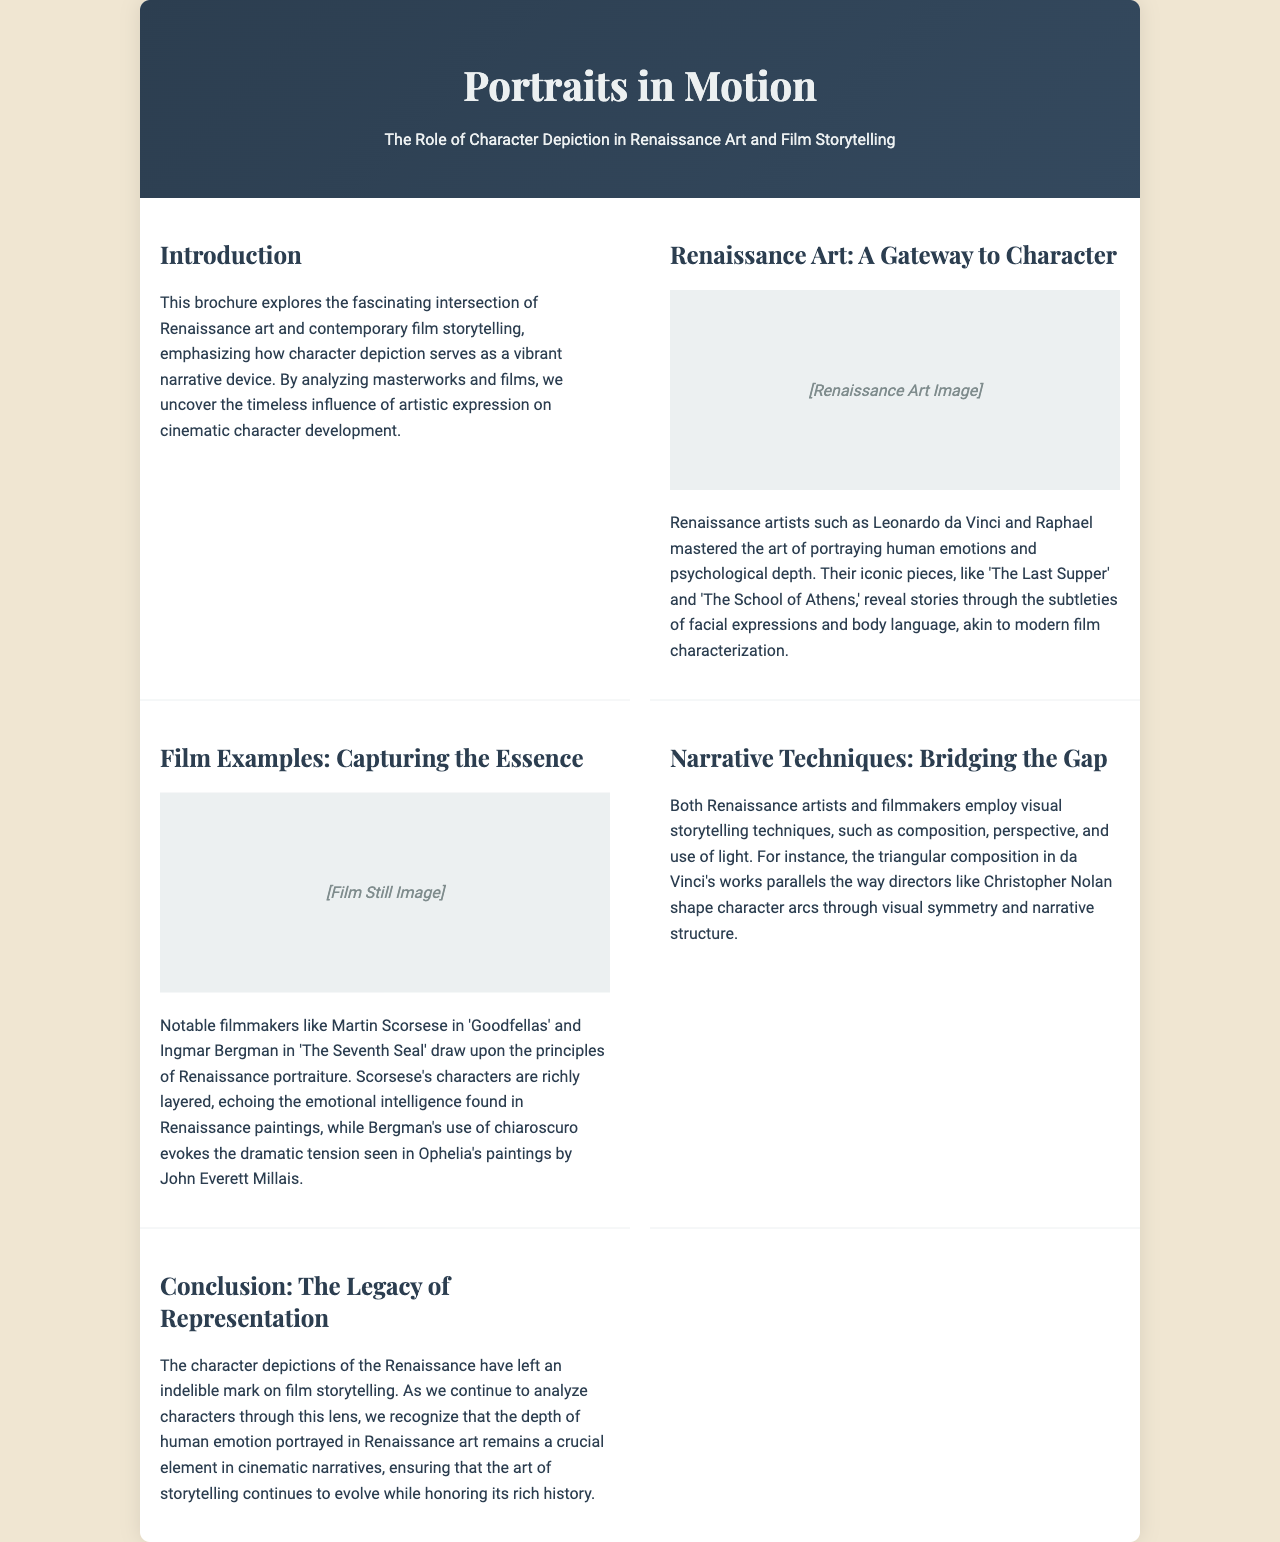What is the title of the brochure? The title is clearly stated at the top of the document, which is "Portraits in Motion."
Answer: Portraits in Motion Who are two Renaissance artists mentioned? The document lists Leonardo da Vinci and Raphael as examples of Renaissance artists.
Answer: Leonardo da Vinci and Raphael Name one film by Martin Scorsese referenced in the brochure. The brochure specifically mentions "Goodfellas" as a film by Martin Scorsese.
Answer: Goodfellas What narrative technique is used by both Renaissance artists and filmmakers? The document highlights the use of composition as a narrative technique common to both.
Answer: Composition What influences contemporary film storytelling according to the brochure? The brochure states that character depictions in Renaissance art influence contemporary film storytelling.
Answer: Character depictions in Renaissance art How do Renaissance artworks communicate emotions? The document mentions that Renaissance artworks communicate emotions through facial expressions and body language.
Answer: Facial expressions and body language What year is the latest art analysis covered in the document? The document doesn't specify a year for the latest analysis, indicating a focus on timeless artistic influences.
Answer: Not specified Which filmmaker's use of chiaroscuro is mentioned in the brochure? The document references Ingmar Bergman's use of chiaroscuro as notable.
Answer: Ingmar Bergman What is the primary focus of the brochure? The primary focus of the brochure is the intersection of Renaissance art and contemporary film storytelling.
Answer: Intersection of Renaissance art and contemporary film storytelling 